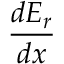<formula> <loc_0><loc_0><loc_500><loc_500>\frac { d E _ { r } } { d x }</formula> 